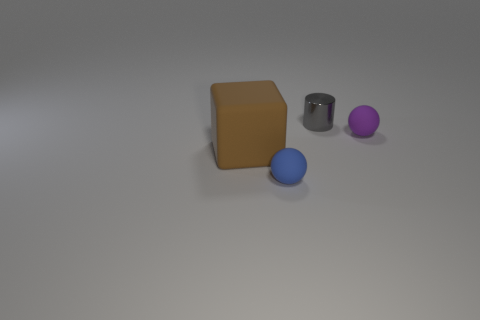Add 4 blue cylinders. How many objects exist? 8 Subtract all purple spheres. How many spheres are left? 1 Subtract all blocks. How many objects are left? 3 Subtract 1 balls. How many balls are left? 1 Add 4 brown matte things. How many brown matte things are left? 5 Add 3 big brown rubber blocks. How many big brown rubber blocks exist? 4 Subtract 1 blue balls. How many objects are left? 3 Subtract all purple blocks. Subtract all red spheres. How many blocks are left? 1 Subtract all blue balls. How many gray cubes are left? 0 Subtract all big blue rubber blocks. Subtract all brown things. How many objects are left? 3 